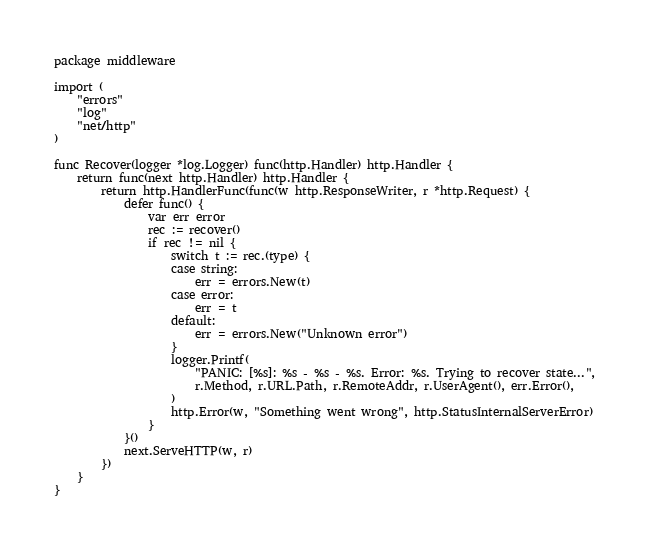Convert code to text. <code><loc_0><loc_0><loc_500><loc_500><_Go_>package middleware

import (
	"errors"
	"log"
	"net/http"
)

func Recover(logger *log.Logger) func(http.Handler) http.Handler {
	return func(next http.Handler) http.Handler {
		return http.HandlerFunc(func(w http.ResponseWriter, r *http.Request) {
			defer func() {
				var err error
				rec := recover()
				if rec != nil {
					switch t := rec.(type) {
					case string:
						err = errors.New(t)
					case error:
						err = t
					default:
						err = errors.New("Unknown error")
					}
					logger.Printf(
						"PANIC: [%s]: %s - %s - %s. Error: %s. Trying to recover state...",
						r.Method, r.URL.Path, r.RemoteAddr, r.UserAgent(), err.Error(),
					)
					http.Error(w, "Something went wrong", http.StatusInternalServerError)
				}
			}()
			next.ServeHTTP(w, r)
		})
	}
}
</code> 